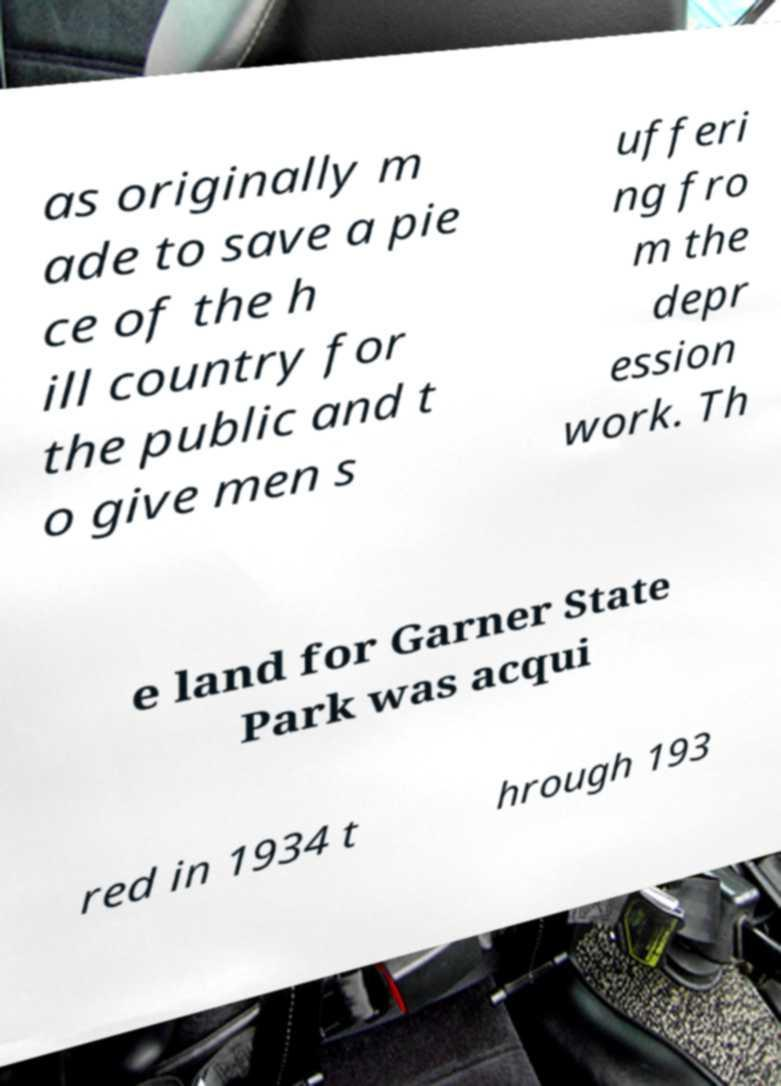What messages or text are displayed in this image? I need them in a readable, typed format. as originally m ade to save a pie ce of the h ill country for the public and t o give men s ufferi ng fro m the depr ession work. Th e land for Garner State Park was acqui red in 1934 t hrough 193 